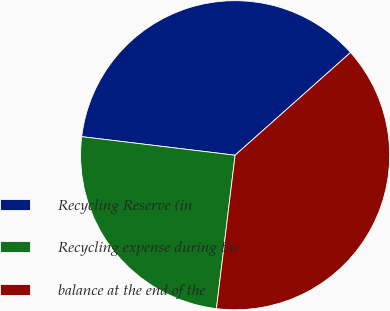Convert chart to OTSL. <chart><loc_0><loc_0><loc_500><loc_500><pie_chart><fcel>Recycling Reserve (in<fcel>Recycling expense during the<fcel>balance at the end of the<nl><fcel>36.51%<fcel>24.99%<fcel>38.5%<nl></chart> 